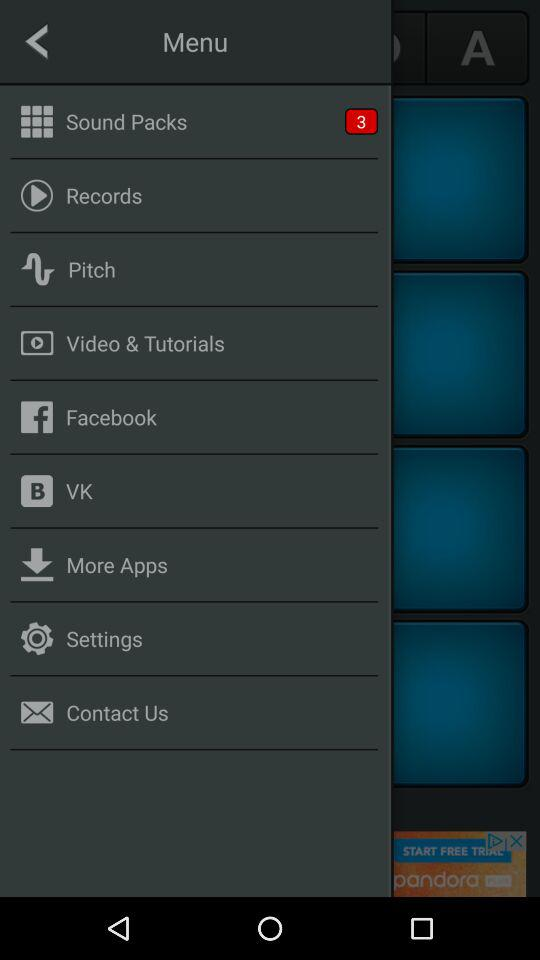How many sound packs are available? There are 3 sound packs available. 